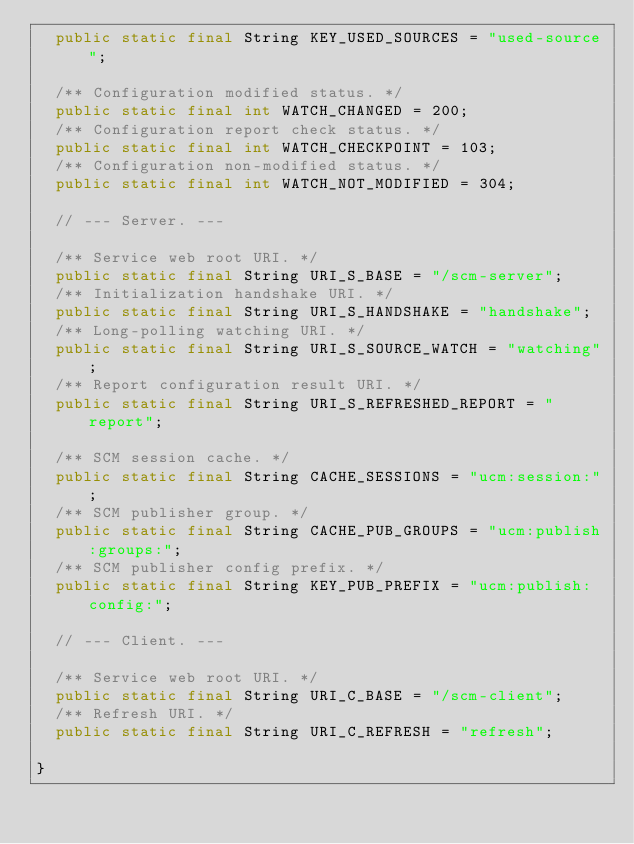<code> <loc_0><loc_0><loc_500><loc_500><_Java_>	public static final String KEY_USED_SOURCES = "used-source";

	/** Configuration modified status. */
	public static final int WATCH_CHANGED = 200;
	/** Configuration report check status. */
	public static final int WATCH_CHECKPOINT = 103;
	/** Configuration non-modified status. */
	public static final int WATCH_NOT_MODIFIED = 304;

	// --- Server. ---

	/** Service web root URI. */
	public static final String URI_S_BASE = "/scm-server";
	/** Initialization handshake URI. */
	public static final String URI_S_HANDSHAKE = "handshake";
	/** Long-polling watching URI. */
	public static final String URI_S_SOURCE_WATCH = "watching";
	/** Report configuration result URI. */
	public static final String URI_S_REFRESHED_REPORT = "report";

	/** SCM session cache. */
	public static final String CACHE_SESSIONS = "ucm:session:";
	/** SCM publisher group. */
	public static final String CACHE_PUB_GROUPS = "ucm:publish:groups:";
	/** SCM publisher config prefix. */
	public static final String KEY_PUB_PREFIX = "ucm:publish:config:";

	// --- Client. ---

	/** Service web root URI. */
	public static final String URI_C_BASE = "/scm-client";
	/** Refresh URI. */
	public static final String URI_C_REFRESH = "refresh";

}</code> 